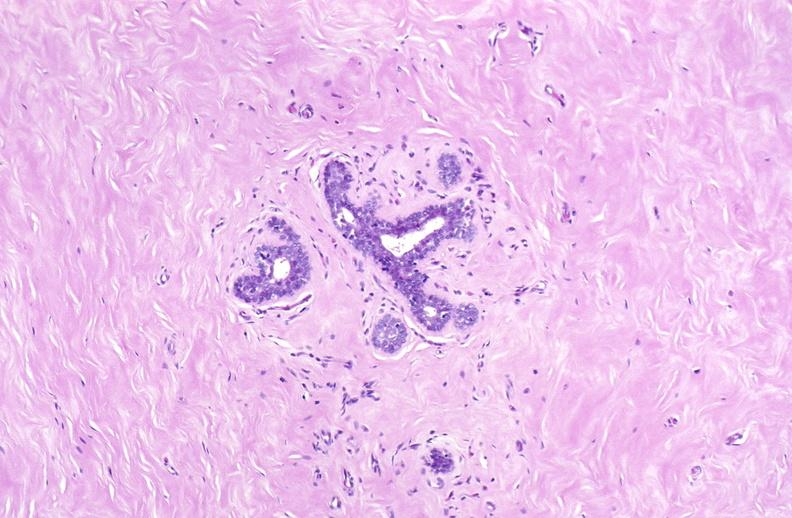where is this area in the body?
Answer the question using a single word or phrase. Breast 